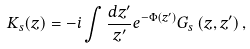<formula> <loc_0><loc_0><loc_500><loc_500>K _ { s } ( z ) = - i \int \frac { d z ^ { \prime } } { z ^ { \prime } } e ^ { - \Phi ( z ^ { \prime } ) } G _ { s } \left ( z , z ^ { \prime } \right ) ,</formula> 